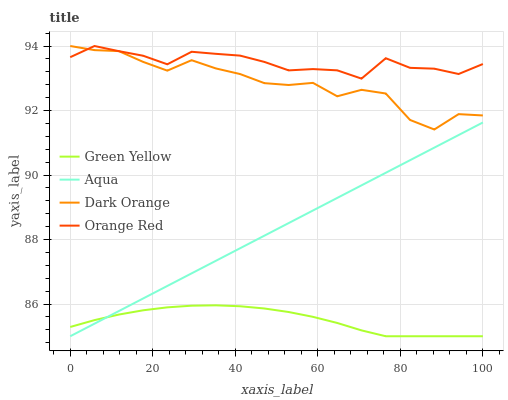Does Green Yellow have the minimum area under the curve?
Answer yes or no. Yes. Does Orange Red have the maximum area under the curve?
Answer yes or no. Yes. Does Aqua have the minimum area under the curve?
Answer yes or no. No. Does Aqua have the maximum area under the curve?
Answer yes or no. No. Is Aqua the smoothest?
Answer yes or no. Yes. Is Dark Orange the roughest?
Answer yes or no. Yes. Is Green Yellow the smoothest?
Answer yes or no. No. Is Green Yellow the roughest?
Answer yes or no. No. Does Green Yellow have the lowest value?
Answer yes or no. Yes. Does Orange Red have the lowest value?
Answer yes or no. No. Does Orange Red have the highest value?
Answer yes or no. Yes. Does Aqua have the highest value?
Answer yes or no. No. Is Green Yellow less than Orange Red?
Answer yes or no. Yes. Is Dark Orange greater than Aqua?
Answer yes or no. Yes. Does Orange Red intersect Dark Orange?
Answer yes or no. Yes. Is Orange Red less than Dark Orange?
Answer yes or no. No. Is Orange Red greater than Dark Orange?
Answer yes or no. No. Does Green Yellow intersect Orange Red?
Answer yes or no. No. 